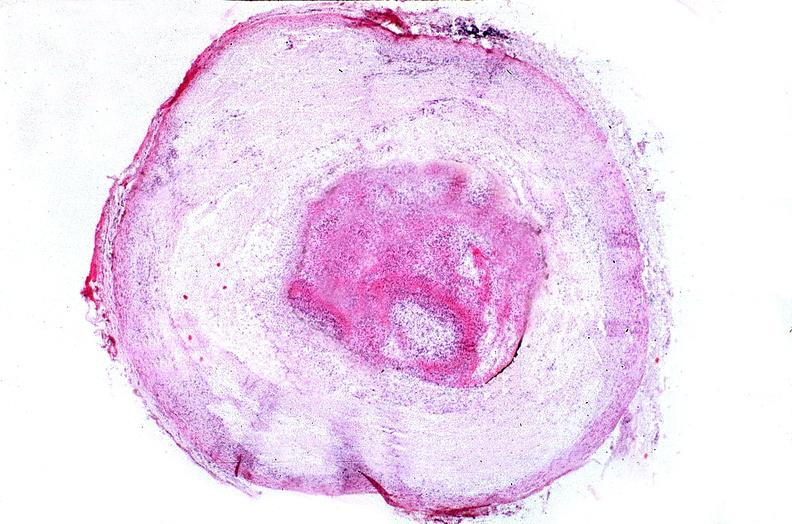what is present?
Answer the question using a single word or phrase. Vasculature 